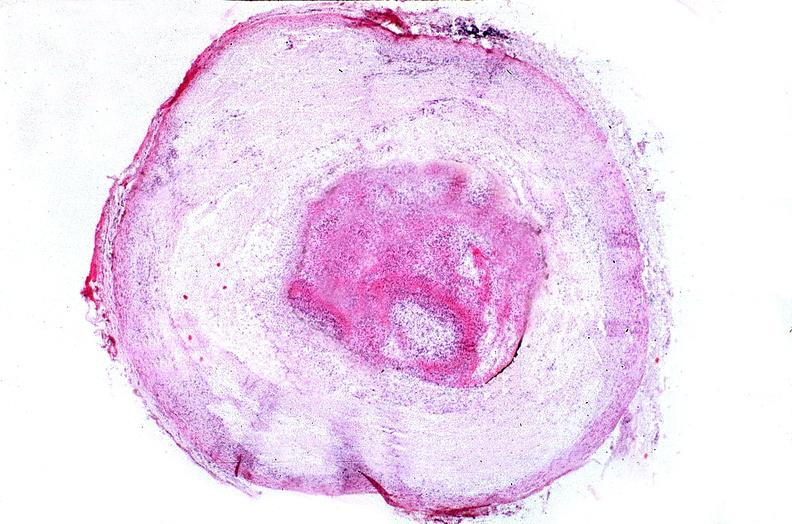what is present?
Answer the question using a single word or phrase. Vasculature 